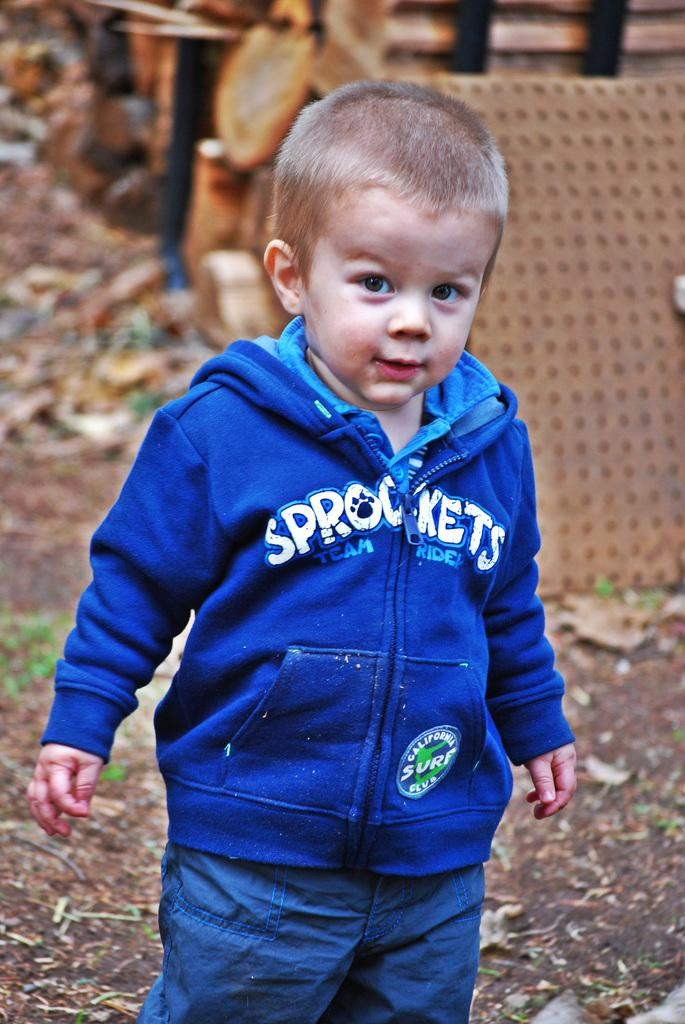<image>
Render a clear and concise summary of the photo. a boy with a sprockets jacket on himself 